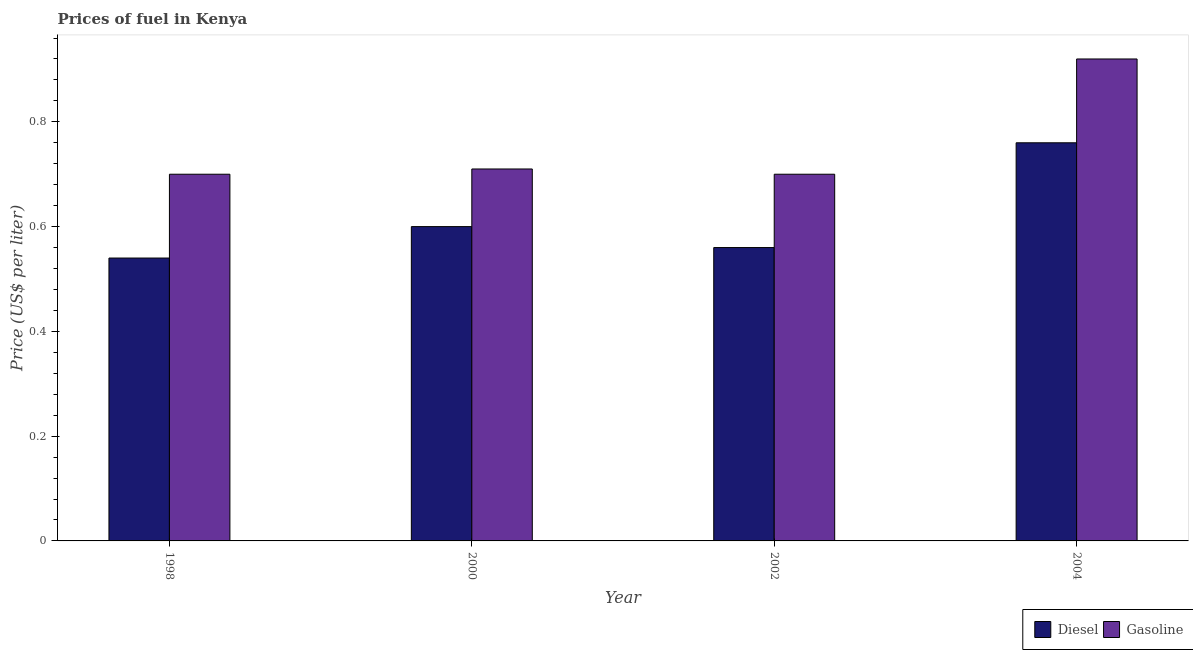How many different coloured bars are there?
Offer a terse response. 2. Are the number of bars per tick equal to the number of legend labels?
Give a very brief answer. Yes. How many bars are there on the 3rd tick from the left?
Give a very brief answer. 2. Across all years, what is the maximum diesel price?
Make the answer very short. 0.76. Across all years, what is the minimum diesel price?
Give a very brief answer. 0.54. In which year was the gasoline price maximum?
Keep it short and to the point. 2004. What is the total gasoline price in the graph?
Your response must be concise. 3.03. What is the difference between the diesel price in 1998 and that in 2002?
Keep it short and to the point. -0.02. What is the difference between the gasoline price in 2000 and the diesel price in 1998?
Your answer should be compact. 0.01. What is the average gasoline price per year?
Make the answer very short. 0.76. In the year 2000, what is the difference between the gasoline price and diesel price?
Your response must be concise. 0. What is the ratio of the diesel price in 2000 to that in 2004?
Ensure brevity in your answer.  0.79. Is the diesel price in 2000 less than that in 2004?
Offer a terse response. Yes. Is the difference between the diesel price in 1998 and 2002 greater than the difference between the gasoline price in 1998 and 2002?
Make the answer very short. No. What is the difference between the highest and the second highest gasoline price?
Provide a succinct answer. 0.21. What is the difference between the highest and the lowest gasoline price?
Your answer should be very brief. 0.22. What does the 2nd bar from the left in 2000 represents?
Give a very brief answer. Gasoline. What does the 1st bar from the right in 2000 represents?
Your answer should be very brief. Gasoline. How many bars are there?
Your answer should be very brief. 8. What is the difference between two consecutive major ticks on the Y-axis?
Provide a succinct answer. 0.2. Does the graph contain any zero values?
Your answer should be very brief. No. Does the graph contain grids?
Keep it short and to the point. No. Where does the legend appear in the graph?
Give a very brief answer. Bottom right. How many legend labels are there?
Your answer should be compact. 2. How are the legend labels stacked?
Make the answer very short. Horizontal. What is the title of the graph?
Keep it short and to the point. Prices of fuel in Kenya. Does "Depositors" appear as one of the legend labels in the graph?
Provide a succinct answer. No. What is the label or title of the X-axis?
Offer a very short reply. Year. What is the label or title of the Y-axis?
Offer a terse response. Price (US$ per liter). What is the Price (US$ per liter) of Diesel in 1998?
Offer a terse response. 0.54. What is the Price (US$ per liter) of Gasoline in 1998?
Your response must be concise. 0.7. What is the Price (US$ per liter) in Gasoline in 2000?
Provide a succinct answer. 0.71. What is the Price (US$ per liter) in Diesel in 2002?
Provide a succinct answer. 0.56. What is the Price (US$ per liter) in Gasoline in 2002?
Your answer should be very brief. 0.7. What is the Price (US$ per liter) in Diesel in 2004?
Provide a succinct answer. 0.76. Across all years, what is the maximum Price (US$ per liter) in Diesel?
Your response must be concise. 0.76. Across all years, what is the maximum Price (US$ per liter) in Gasoline?
Your answer should be very brief. 0.92. Across all years, what is the minimum Price (US$ per liter) in Diesel?
Give a very brief answer. 0.54. What is the total Price (US$ per liter) in Diesel in the graph?
Make the answer very short. 2.46. What is the total Price (US$ per liter) of Gasoline in the graph?
Provide a short and direct response. 3.03. What is the difference between the Price (US$ per liter) in Diesel in 1998 and that in 2000?
Ensure brevity in your answer.  -0.06. What is the difference between the Price (US$ per liter) of Gasoline in 1998 and that in 2000?
Provide a short and direct response. -0.01. What is the difference between the Price (US$ per liter) of Diesel in 1998 and that in 2002?
Give a very brief answer. -0.02. What is the difference between the Price (US$ per liter) in Gasoline in 1998 and that in 2002?
Offer a terse response. 0. What is the difference between the Price (US$ per liter) of Diesel in 1998 and that in 2004?
Provide a succinct answer. -0.22. What is the difference between the Price (US$ per liter) of Gasoline in 1998 and that in 2004?
Your response must be concise. -0.22. What is the difference between the Price (US$ per liter) in Diesel in 2000 and that in 2004?
Offer a terse response. -0.16. What is the difference between the Price (US$ per liter) of Gasoline in 2000 and that in 2004?
Give a very brief answer. -0.21. What is the difference between the Price (US$ per liter) of Gasoline in 2002 and that in 2004?
Give a very brief answer. -0.22. What is the difference between the Price (US$ per liter) in Diesel in 1998 and the Price (US$ per liter) in Gasoline in 2000?
Your answer should be compact. -0.17. What is the difference between the Price (US$ per liter) in Diesel in 1998 and the Price (US$ per liter) in Gasoline in 2002?
Ensure brevity in your answer.  -0.16. What is the difference between the Price (US$ per liter) in Diesel in 1998 and the Price (US$ per liter) in Gasoline in 2004?
Your response must be concise. -0.38. What is the difference between the Price (US$ per liter) of Diesel in 2000 and the Price (US$ per liter) of Gasoline in 2002?
Give a very brief answer. -0.1. What is the difference between the Price (US$ per liter) in Diesel in 2000 and the Price (US$ per liter) in Gasoline in 2004?
Provide a short and direct response. -0.32. What is the difference between the Price (US$ per liter) in Diesel in 2002 and the Price (US$ per liter) in Gasoline in 2004?
Provide a short and direct response. -0.36. What is the average Price (US$ per liter) of Diesel per year?
Make the answer very short. 0.61. What is the average Price (US$ per liter) of Gasoline per year?
Offer a very short reply. 0.76. In the year 1998, what is the difference between the Price (US$ per liter) of Diesel and Price (US$ per liter) of Gasoline?
Your answer should be compact. -0.16. In the year 2000, what is the difference between the Price (US$ per liter) of Diesel and Price (US$ per liter) of Gasoline?
Keep it short and to the point. -0.11. In the year 2002, what is the difference between the Price (US$ per liter) of Diesel and Price (US$ per liter) of Gasoline?
Provide a short and direct response. -0.14. In the year 2004, what is the difference between the Price (US$ per liter) in Diesel and Price (US$ per liter) in Gasoline?
Your answer should be very brief. -0.16. What is the ratio of the Price (US$ per liter) in Gasoline in 1998 to that in 2000?
Provide a short and direct response. 0.99. What is the ratio of the Price (US$ per liter) of Diesel in 1998 to that in 2004?
Make the answer very short. 0.71. What is the ratio of the Price (US$ per liter) of Gasoline in 1998 to that in 2004?
Offer a very short reply. 0.76. What is the ratio of the Price (US$ per liter) of Diesel in 2000 to that in 2002?
Provide a succinct answer. 1.07. What is the ratio of the Price (US$ per liter) of Gasoline in 2000 to that in 2002?
Provide a succinct answer. 1.01. What is the ratio of the Price (US$ per liter) in Diesel in 2000 to that in 2004?
Your answer should be compact. 0.79. What is the ratio of the Price (US$ per liter) in Gasoline in 2000 to that in 2004?
Keep it short and to the point. 0.77. What is the ratio of the Price (US$ per liter) of Diesel in 2002 to that in 2004?
Ensure brevity in your answer.  0.74. What is the ratio of the Price (US$ per liter) in Gasoline in 2002 to that in 2004?
Provide a short and direct response. 0.76. What is the difference between the highest and the second highest Price (US$ per liter) of Diesel?
Your response must be concise. 0.16. What is the difference between the highest and the second highest Price (US$ per liter) in Gasoline?
Provide a succinct answer. 0.21. What is the difference between the highest and the lowest Price (US$ per liter) in Diesel?
Your answer should be compact. 0.22. What is the difference between the highest and the lowest Price (US$ per liter) in Gasoline?
Keep it short and to the point. 0.22. 